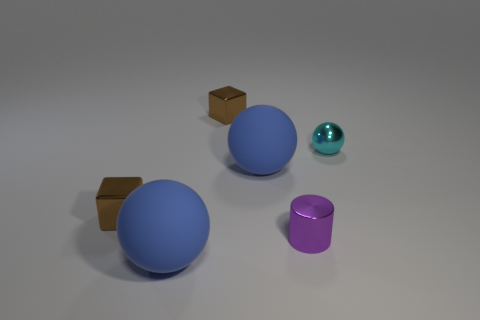Add 2 small red shiny cylinders. How many objects exist? 8 Subtract all blocks. How many objects are left? 4 Add 3 large yellow cubes. How many large yellow cubes exist? 3 Subtract 0 gray cylinders. How many objects are left? 6 Subtract all large blue spheres. Subtract all brown metallic cubes. How many objects are left? 2 Add 3 small shiny cylinders. How many small shiny cylinders are left? 4 